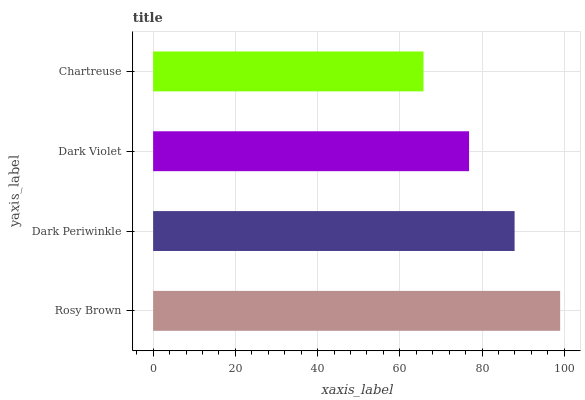Is Chartreuse the minimum?
Answer yes or no. Yes. Is Rosy Brown the maximum?
Answer yes or no. Yes. Is Dark Periwinkle the minimum?
Answer yes or no. No. Is Dark Periwinkle the maximum?
Answer yes or no. No. Is Rosy Brown greater than Dark Periwinkle?
Answer yes or no. Yes. Is Dark Periwinkle less than Rosy Brown?
Answer yes or no. Yes. Is Dark Periwinkle greater than Rosy Brown?
Answer yes or no. No. Is Rosy Brown less than Dark Periwinkle?
Answer yes or no. No. Is Dark Periwinkle the high median?
Answer yes or no. Yes. Is Dark Violet the low median?
Answer yes or no. Yes. Is Rosy Brown the high median?
Answer yes or no. No. Is Rosy Brown the low median?
Answer yes or no. No. 